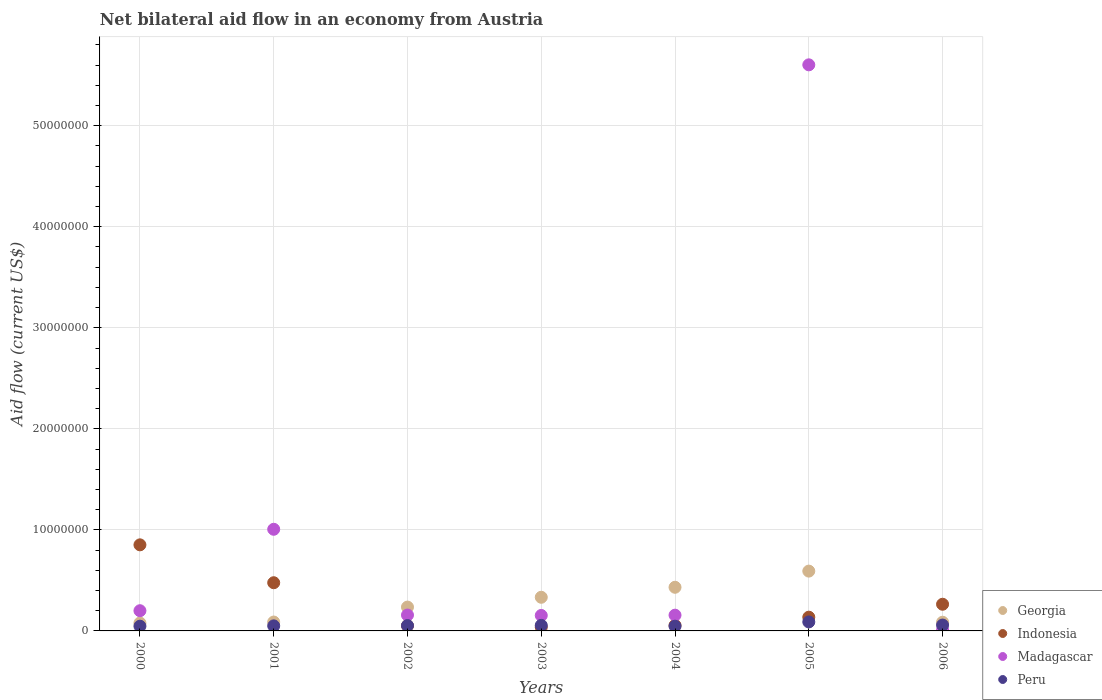How many different coloured dotlines are there?
Keep it short and to the point. 4. Is the number of dotlines equal to the number of legend labels?
Make the answer very short. Yes. What is the net bilateral aid flow in Indonesia in 2005?
Offer a terse response. 1.36e+06. Across all years, what is the maximum net bilateral aid flow in Indonesia?
Your answer should be compact. 8.52e+06. What is the total net bilateral aid flow in Madagascar in the graph?
Your answer should be very brief. 7.28e+07. What is the difference between the net bilateral aid flow in Madagascar in 2005 and the net bilateral aid flow in Peru in 2001?
Keep it short and to the point. 5.55e+07. What is the average net bilateral aid flow in Indonesia per year?
Offer a very short reply. 2.68e+06. In the year 2000, what is the difference between the net bilateral aid flow in Peru and net bilateral aid flow in Georgia?
Your answer should be very brief. -3.10e+05. In how many years, is the net bilateral aid flow in Georgia greater than 54000000 US$?
Provide a short and direct response. 0. What is the ratio of the net bilateral aid flow in Peru in 2000 to that in 2003?
Your response must be concise. 0.85. What is the difference between the highest and the second highest net bilateral aid flow in Peru?
Ensure brevity in your answer.  3.10e+05. What is the difference between the highest and the lowest net bilateral aid flow in Georgia?
Make the answer very short. 5.14e+06. Is the sum of the net bilateral aid flow in Peru in 2005 and 2006 greater than the maximum net bilateral aid flow in Indonesia across all years?
Offer a very short reply. No. How many dotlines are there?
Give a very brief answer. 4. How many years are there in the graph?
Provide a succinct answer. 7. Are the values on the major ticks of Y-axis written in scientific E-notation?
Offer a very short reply. No. Does the graph contain any zero values?
Provide a short and direct response. No. How many legend labels are there?
Give a very brief answer. 4. How are the legend labels stacked?
Keep it short and to the point. Vertical. What is the title of the graph?
Make the answer very short. Net bilateral aid flow in an economy from Austria. What is the label or title of the X-axis?
Your response must be concise. Years. What is the label or title of the Y-axis?
Provide a succinct answer. Aid flow (current US$). What is the Aid flow (current US$) of Georgia in 2000?
Give a very brief answer. 7.80e+05. What is the Aid flow (current US$) in Indonesia in 2000?
Make the answer very short. 8.52e+06. What is the Aid flow (current US$) of Madagascar in 2000?
Provide a short and direct response. 2.00e+06. What is the Aid flow (current US$) of Georgia in 2001?
Provide a short and direct response. 8.80e+05. What is the Aid flow (current US$) in Indonesia in 2001?
Provide a short and direct response. 4.77e+06. What is the Aid flow (current US$) in Madagascar in 2001?
Your answer should be compact. 1.01e+07. What is the Aid flow (current US$) of Georgia in 2002?
Provide a short and direct response. 2.36e+06. What is the Aid flow (current US$) of Indonesia in 2002?
Ensure brevity in your answer.  5.20e+05. What is the Aid flow (current US$) of Madagascar in 2002?
Offer a terse response. 1.57e+06. What is the Aid flow (current US$) in Peru in 2002?
Ensure brevity in your answer.  5.30e+05. What is the Aid flow (current US$) in Georgia in 2003?
Keep it short and to the point. 3.33e+06. What is the Aid flow (current US$) in Indonesia in 2003?
Make the answer very short. 3.70e+05. What is the Aid flow (current US$) in Madagascar in 2003?
Give a very brief answer. 1.53e+06. What is the Aid flow (current US$) in Peru in 2003?
Offer a terse response. 5.50e+05. What is the Aid flow (current US$) of Georgia in 2004?
Provide a short and direct response. 4.32e+06. What is the Aid flow (current US$) in Madagascar in 2004?
Give a very brief answer. 1.56e+06. What is the Aid flow (current US$) of Georgia in 2005?
Your answer should be very brief. 5.92e+06. What is the Aid flow (current US$) in Indonesia in 2005?
Your response must be concise. 1.36e+06. What is the Aid flow (current US$) in Madagascar in 2005?
Ensure brevity in your answer.  5.60e+07. What is the Aid flow (current US$) in Peru in 2005?
Your answer should be very brief. 8.90e+05. What is the Aid flow (current US$) of Georgia in 2006?
Keep it short and to the point. 8.60e+05. What is the Aid flow (current US$) in Indonesia in 2006?
Your answer should be compact. 2.64e+06. What is the Aid flow (current US$) of Peru in 2006?
Keep it short and to the point. 5.80e+05. Across all years, what is the maximum Aid flow (current US$) in Georgia?
Provide a succinct answer. 5.92e+06. Across all years, what is the maximum Aid flow (current US$) of Indonesia?
Give a very brief answer. 8.52e+06. Across all years, what is the maximum Aid flow (current US$) of Madagascar?
Your answer should be very brief. 5.60e+07. Across all years, what is the maximum Aid flow (current US$) in Peru?
Ensure brevity in your answer.  8.90e+05. Across all years, what is the minimum Aid flow (current US$) of Georgia?
Your answer should be compact. 7.80e+05. Across all years, what is the minimum Aid flow (current US$) in Madagascar?
Your answer should be very brief. 9.00e+04. What is the total Aid flow (current US$) of Georgia in the graph?
Provide a short and direct response. 1.84e+07. What is the total Aid flow (current US$) of Indonesia in the graph?
Your answer should be compact. 1.87e+07. What is the total Aid flow (current US$) in Madagascar in the graph?
Your answer should be compact. 7.28e+07. What is the total Aid flow (current US$) in Peru in the graph?
Offer a very short reply. 3.99e+06. What is the difference between the Aid flow (current US$) of Georgia in 2000 and that in 2001?
Provide a short and direct response. -1.00e+05. What is the difference between the Aid flow (current US$) of Indonesia in 2000 and that in 2001?
Give a very brief answer. 3.75e+06. What is the difference between the Aid flow (current US$) in Madagascar in 2000 and that in 2001?
Offer a very short reply. -8.06e+06. What is the difference between the Aid flow (current US$) of Georgia in 2000 and that in 2002?
Your answer should be compact. -1.58e+06. What is the difference between the Aid flow (current US$) in Indonesia in 2000 and that in 2002?
Ensure brevity in your answer.  8.00e+06. What is the difference between the Aid flow (current US$) of Peru in 2000 and that in 2002?
Provide a short and direct response. -6.00e+04. What is the difference between the Aid flow (current US$) of Georgia in 2000 and that in 2003?
Your answer should be compact. -2.55e+06. What is the difference between the Aid flow (current US$) in Indonesia in 2000 and that in 2003?
Offer a very short reply. 8.15e+06. What is the difference between the Aid flow (current US$) of Georgia in 2000 and that in 2004?
Offer a terse response. -3.54e+06. What is the difference between the Aid flow (current US$) in Indonesia in 2000 and that in 2004?
Your response must be concise. 7.97e+06. What is the difference between the Aid flow (current US$) of Madagascar in 2000 and that in 2004?
Provide a short and direct response. 4.40e+05. What is the difference between the Aid flow (current US$) in Peru in 2000 and that in 2004?
Your answer should be compact. 0. What is the difference between the Aid flow (current US$) of Georgia in 2000 and that in 2005?
Offer a terse response. -5.14e+06. What is the difference between the Aid flow (current US$) of Indonesia in 2000 and that in 2005?
Offer a very short reply. 7.16e+06. What is the difference between the Aid flow (current US$) of Madagascar in 2000 and that in 2005?
Give a very brief answer. -5.40e+07. What is the difference between the Aid flow (current US$) of Peru in 2000 and that in 2005?
Keep it short and to the point. -4.20e+05. What is the difference between the Aid flow (current US$) of Georgia in 2000 and that in 2006?
Make the answer very short. -8.00e+04. What is the difference between the Aid flow (current US$) of Indonesia in 2000 and that in 2006?
Provide a short and direct response. 5.88e+06. What is the difference between the Aid flow (current US$) in Madagascar in 2000 and that in 2006?
Keep it short and to the point. 1.91e+06. What is the difference between the Aid flow (current US$) of Peru in 2000 and that in 2006?
Keep it short and to the point. -1.10e+05. What is the difference between the Aid flow (current US$) in Georgia in 2001 and that in 2002?
Give a very brief answer. -1.48e+06. What is the difference between the Aid flow (current US$) in Indonesia in 2001 and that in 2002?
Your answer should be compact. 4.25e+06. What is the difference between the Aid flow (current US$) in Madagascar in 2001 and that in 2002?
Keep it short and to the point. 8.49e+06. What is the difference between the Aid flow (current US$) in Peru in 2001 and that in 2002?
Offer a terse response. -3.00e+04. What is the difference between the Aid flow (current US$) in Georgia in 2001 and that in 2003?
Your response must be concise. -2.45e+06. What is the difference between the Aid flow (current US$) in Indonesia in 2001 and that in 2003?
Ensure brevity in your answer.  4.40e+06. What is the difference between the Aid flow (current US$) in Madagascar in 2001 and that in 2003?
Give a very brief answer. 8.53e+06. What is the difference between the Aid flow (current US$) of Peru in 2001 and that in 2003?
Provide a short and direct response. -5.00e+04. What is the difference between the Aid flow (current US$) of Georgia in 2001 and that in 2004?
Your answer should be very brief. -3.44e+06. What is the difference between the Aid flow (current US$) of Indonesia in 2001 and that in 2004?
Ensure brevity in your answer.  4.22e+06. What is the difference between the Aid flow (current US$) in Madagascar in 2001 and that in 2004?
Ensure brevity in your answer.  8.50e+06. What is the difference between the Aid flow (current US$) of Peru in 2001 and that in 2004?
Ensure brevity in your answer.  3.00e+04. What is the difference between the Aid flow (current US$) of Georgia in 2001 and that in 2005?
Your answer should be compact. -5.04e+06. What is the difference between the Aid flow (current US$) of Indonesia in 2001 and that in 2005?
Make the answer very short. 3.41e+06. What is the difference between the Aid flow (current US$) in Madagascar in 2001 and that in 2005?
Provide a succinct answer. -4.60e+07. What is the difference between the Aid flow (current US$) in Peru in 2001 and that in 2005?
Give a very brief answer. -3.90e+05. What is the difference between the Aid flow (current US$) of Georgia in 2001 and that in 2006?
Keep it short and to the point. 2.00e+04. What is the difference between the Aid flow (current US$) in Indonesia in 2001 and that in 2006?
Your response must be concise. 2.13e+06. What is the difference between the Aid flow (current US$) of Madagascar in 2001 and that in 2006?
Ensure brevity in your answer.  9.97e+06. What is the difference between the Aid flow (current US$) in Peru in 2001 and that in 2006?
Keep it short and to the point. -8.00e+04. What is the difference between the Aid flow (current US$) of Georgia in 2002 and that in 2003?
Your answer should be very brief. -9.70e+05. What is the difference between the Aid flow (current US$) in Peru in 2002 and that in 2003?
Ensure brevity in your answer.  -2.00e+04. What is the difference between the Aid flow (current US$) in Georgia in 2002 and that in 2004?
Offer a terse response. -1.96e+06. What is the difference between the Aid flow (current US$) in Indonesia in 2002 and that in 2004?
Your answer should be compact. -3.00e+04. What is the difference between the Aid flow (current US$) of Peru in 2002 and that in 2004?
Your answer should be compact. 6.00e+04. What is the difference between the Aid flow (current US$) of Georgia in 2002 and that in 2005?
Make the answer very short. -3.56e+06. What is the difference between the Aid flow (current US$) in Indonesia in 2002 and that in 2005?
Ensure brevity in your answer.  -8.40e+05. What is the difference between the Aid flow (current US$) in Madagascar in 2002 and that in 2005?
Provide a succinct answer. -5.45e+07. What is the difference between the Aid flow (current US$) of Peru in 2002 and that in 2005?
Your response must be concise. -3.60e+05. What is the difference between the Aid flow (current US$) in Georgia in 2002 and that in 2006?
Offer a terse response. 1.50e+06. What is the difference between the Aid flow (current US$) in Indonesia in 2002 and that in 2006?
Make the answer very short. -2.12e+06. What is the difference between the Aid flow (current US$) in Madagascar in 2002 and that in 2006?
Offer a terse response. 1.48e+06. What is the difference between the Aid flow (current US$) in Georgia in 2003 and that in 2004?
Give a very brief answer. -9.90e+05. What is the difference between the Aid flow (current US$) of Georgia in 2003 and that in 2005?
Offer a very short reply. -2.59e+06. What is the difference between the Aid flow (current US$) in Indonesia in 2003 and that in 2005?
Give a very brief answer. -9.90e+05. What is the difference between the Aid flow (current US$) in Madagascar in 2003 and that in 2005?
Offer a very short reply. -5.45e+07. What is the difference between the Aid flow (current US$) in Georgia in 2003 and that in 2006?
Give a very brief answer. 2.47e+06. What is the difference between the Aid flow (current US$) in Indonesia in 2003 and that in 2006?
Offer a terse response. -2.27e+06. What is the difference between the Aid flow (current US$) of Madagascar in 2003 and that in 2006?
Ensure brevity in your answer.  1.44e+06. What is the difference between the Aid flow (current US$) in Georgia in 2004 and that in 2005?
Your answer should be compact. -1.60e+06. What is the difference between the Aid flow (current US$) in Indonesia in 2004 and that in 2005?
Your answer should be compact. -8.10e+05. What is the difference between the Aid flow (current US$) in Madagascar in 2004 and that in 2005?
Ensure brevity in your answer.  -5.45e+07. What is the difference between the Aid flow (current US$) of Peru in 2004 and that in 2005?
Provide a short and direct response. -4.20e+05. What is the difference between the Aid flow (current US$) in Georgia in 2004 and that in 2006?
Keep it short and to the point. 3.46e+06. What is the difference between the Aid flow (current US$) of Indonesia in 2004 and that in 2006?
Provide a succinct answer. -2.09e+06. What is the difference between the Aid flow (current US$) in Madagascar in 2004 and that in 2006?
Provide a short and direct response. 1.47e+06. What is the difference between the Aid flow (current US$) in Georgia in 2005 and that in 2006?
Provide a succinct answer. 5.06e+06. What is the difference between the Aid flow (current US$) of Indonesia in 2005 and that in 2006?
Your answer should be compact. -1.28e+06. What is the difference between the Aid flow (current US$) in Madagascar in 2005 and that in 2006?
Give a very brief answer. 5.59e+07. What is the difference between the Aid flow (current US$) of Peru in 2005 and that in 2006?
Provide a short and direct response. 3.10e+05. What is the difference between the Aid flow (current US$) in Georgia in 2000 and the Aid flow (current US$) in Indonesia in 2001?
Ensure brevity in your answer.  -3.99e+06. What is the difference between the Aid flow (current US$) of Georgia in 2000 and the Aid flow (current US$) of Madagascar in 2001?
Keep it short and to the point. -9.28e+06. What is the difference between the Aid flow (current US$) of Indonesia in 2000 and the Aid flow (current US$) of Madagascar in 2001?
Give a very brief answer. -1.54e+06. What is the difference between the Aid flow (current US$) in Indonesia in 2000 and the Aid flow (current US$) in Peru in 2001?
Your answer should be very brief. 8.02e+06. What is the difference between the Aid flow (current US$) of Madagascar in 2000 and the Aid flow (current US$) of Peru in 2001?
Your answer should be very brief. 1.50e+06. What is the difference between the Aid flow (current US$) of Georgia in 2000 and the Aid flow (current US$) of Madagascar in 2002?
Make the answer very short. -7.90e+05. What is the difference between the Aid flow (current US$) in Indonesia in 2000 and the Aid flow (current US$) in Madagascar in 2002?
Make the answer very short. 6.95e+06. What is the difference between the Aid flow (current US$) in Indonesia in 2000 and the Aid flow (current US$) in Peru in 2002?
Provide a short and direct response. 7.99e+06. What is the difference between the Aid flow (current US$) of Madagascar in 2000 and the Aid flow (current US$) of Peru in 2002?
Provide a short and direct response. 1.47e+06. What is the difference between the Aid flow (current US$) in Georgia in 2000 and the Aid flow (current US$) in Madagascar in 2003?
Offer a terse response. -7.50e+05. What is the difference between the Aid flow (current US$) in Indonesia in 2000 and the Aid flow (current US$) in Madagascar in 2003?
Your response must be concise. 6.99e+06. What is the difference between the Aid flow (current US$) in Indonesia in 2000 and the Aid flow (current US$) in Peru in 2003?
Provide a succinct answer. 7.97e+06. What is the difference between the Aid flow (current US$) in Madagascar in 2000 and the Aid flow (current US$) in Peru in 2003?
Offer a terse response. 1.45e+06. What is the difference between the Aid flow (current US$) in Georgia in 2000 and the Aid flow (current US$) in Indonesia in 2004?
Keep it short and to the point. 2.30e+05. What is the difference between the Aid flow (current US$) in Georgia in 2000 and the Aid flow (current US$) in Madagascar in 2004?
Your answer should be compact. -7.80e+05. What is the difference between the Aid flow (current US$) of Georgia in 2000 and the Aid flow (current US$) of Peru in 2004?
Ensure brevity in your answer.  3.10e+05. What is the difference between the Aid flow (current US$) in Indonesia in 2000 and the Aid flow (current US$) in Madagascar in 2004?
Your answer should be compact. 6.96e+06. What is the difference between the Aid flow (current US$) of Indonesia in 2000 and the Aid flow (current US$) of Peru in 2004?
Your response must be concise. 8.05e+06. What is the difference between the Aid flow (current US$) in Madagascar in 2000 and the Aid flow (current US$) in Peru in 2004?
Keep it short and to the point. 1.53e+06. What is the difference between the Aid flow (current US$) in Georgia in 2000 and the Aid flow (current US$) in Indonesia in 2005?
Your answer should be compact. -5.80e+05. What is the difference between the Aid flow (current US$) in Georgia in 2000 and the Aid flow (current US$) in Madagascar in 2005?
Offer a terse response. -5.52e+07. What is the difference between the Aid flow (current US$) of Indonesia in 2000 and the Aid flow (current US$) of Madagascar in 2005?
Ensure brevity in your answer.  -4.75e+07. What is the difference between the Aid flow (current US$) of Indonesia in 2000 and the Aid flow (current US$) of Peru in 2005?
Offer a very short reply. 7.63e+06. What is the difference between the Aid flow (current US$) in Madagascar in 2000 and the Aid flow (current US$) in Peru in 2005?
Your answer should be very brief. 1.11e+06. What is the difference between the Aid flow (current US$) in Georgia in 2000 and the Aid flow (current US$) in Indonesia in 2006?
Provide a short and direct response. -1.86e+06. What is the difference between the Aid flow (current US$) in Georgia in 2000 and the Aid flow (current US$) in Madagascar in 2006?
Make the answer very short. 6.90e+05. What is the difference between the Aid flow (current US$) of Indonesia in 2000 and the Aid flow (current US$) of Madagascar in 2006?
Provide a succinct answer. 8.43e+06. What is the difference between the Aid flow (current US$) of Indonesia in 2000 and the Aid flow (current US$) of Peru in 2006?
Offer a very short reply. 7.94e+06. What is the difference between the Aid flow (current US$) of Madagascar in 2000 and the Aid flow (current US$) of Peru in 2006?
Offer a terse response. 1.42e+06. What is the difference between the Aid flow (current US$) of Georgia in 2001 and the Aid flow (current US$) of Madagascar in 2002?
Your response must be concise. -6.90e+05. What is the difference between the Aid flow (current US$) of Georgia in 2001 and the Aid flow (current US$) of Peru in 2002?
Your response must be concise. 3.50e+05. What is the difference between the Aid flow (current US$) of Indonesia in 2001 and the Aid flow (current US$) of Madagascar in 2002?
Your answer should be very brief. 3.20e+06. What is the difference between the Aid flow (current US$) in Indonesia in 2001 and the Aid flow (current US$) in Peru in 2002?
Keep it short and to the point. 4.24e+06. What is the difference between the Aid flow (current US$) of Madagascar in 2001 and the Aid flow (current US$) of Peru in 2002?
Offer a terse response. 9.53e+06. What is the difference between the Aid flow (current US$) in Georgia in 2001 and the Aid flow (current US$) in Indonesia in 2003?
Give a very brief answer. 5.10e+05. What is the difference between the Aid flow (current US$) in Georgia in 2001 and the Aid flow (current US$) in Madagascar in 2003?
Provide a succinct answer. -6.50e+05. What is the difference between the Aid flow (current US$) of Georgia in 2001 and the Aid flow (current US$) of Peru in 2003?
Offer a terse response. 3.30e+05. What is the difference between the Aid flow (current US$) in Indonesia in 2001 and the Aid flow (current US$) in Madagascar in 2003?
Your answer should be compact. 3.24e+06. What is the difference between the Aid flow (current US$) in Indonesia in 2001 and the Aid flow (current US$) in Peru in 2003?
Ensure brevity in your answer.  4.22e+06. What is the difference between the Aid flow (current US$) of Madagascar in 2001 and the Aid flow (current US$) of Peru in 2003?
Offer a terse response. 9.51e+06. What is the difference between the Aid flow (current US$) of Georgia in 2001 and the Aid flow (current US$) of Madagascar in 2004?
Your answer should be compact. -6.80e+05. What is the difference between the Aid flow (current US$) in Indonesia in 2001 and the Aid flow (current US$) in Madagascar in 2004?
Ensure brevity in your answer.  3.21e+06. What is the difference between the Aid flow (current US$) of Indonesia in 2001 and the Aid flow (current US$) of Peru in 2004?
Your answer should be compact. 4.30e+06. What is the difference between the Aid flow (current US$) in Madagascar in 2001 and the Aid flow (current US$) in Peru in 2004?
Provide a short and direct response. 9.59e+06. What is the difference between the Aid flow (current US$) in Georgia in 2001 and the Aid flow (current US$) in Indonesia in 2005?
Ensure brevity in your answer.  -4.80e+05. What is the difference between the Aid flow (current US$) in Georgia in 2001 and the Aid flow (current US$) in Madagascar in 2005?
Your answer should be compact. -5.52e+07. What is the difference between the Aid flow (current US$) of Indonesia in 2001 and the Aid flow (current US$) of Madagascar in 2005?
Make the answer very short. -5.13e+07. What is the difference between the Aid flow (current US$) in Indonesia in 2001 and the Aid flow (current US$) in Peru in 2005?
Your answer should be very brief. 3.88e+06. What is the difference between the Aid flow (current US$) in Madagascar in 2001 and the Aid flow (current US$) in Peru in 2005?
Ensure brevity in your answer.  9.17e+06. What is the difference between the Aid flow (current US$) of Georgia in 2001 and the Aid flow (current US$) of Indonesia in 2006?
Provide a short and direct response. -1.76e+06. What is the difference between the Aid flow (current US$) of Georgia in 2001 and the Aid flow (current US$) of Madagascar in 2006?
Your answer should be compact. 7.90e+05. What is the difference between the Aid flow (current US$) in Georgia in 2001 and the Aid flow (current US$) in Peru in 2006?
Make the answer very short. 3.00e+05. What is the difference between the Aid flow (current US$) of Indonesia in 2001 and the Aid flow (current US$) of Madagascar in 2006?
Make the answer very short. 4.68e+06. What is the difference between the Aid flow (current US$) of Indonesia in 2001 and the Aid flow (current US$) of Peru in 2006?
Provide a succinct answer. 4.19e+06. What is the difference between the Aid flow (current US$) of Madagascar in 2001 and the Aid flow (current US$) of Peru in 2006?
Your answer should be compact. 9.48e+06. What is the difference between the Aid flow (current US$) of Georgia in 2002 and the Aid flow (current US$) of Indonesia in 2003?
Make the answer very short. 1.99e+06. What is the difference between the Aid flow (current US$) in Georgia in 2002 and the Aid flow (current US$) in Madagascar in 2003?
Your answer should be compact. 8.30e+05. What is the difference between the Aid flow (current US$) in Georgia in 2002 and the Aid flow (current US$) in Peru in 2003?
Provide a succinct answer. 1.81e+06. What is the difference between the Aid flow (current US$) in Indonesia in 2002 and the Aid flow (current US$) in Madagascar in 2003?
Your answer should be compact. -1.01e+06. What is the difference between the Aid flow (current US$) in Indonesia in 2002 and the Aid flow (current US$) in Peru in 2003?
Make the answer very short. -3.00e+04. What is the difference between the Aid flow (current US$) in Madagascar in 2002 and the Aid flow (current US$) in Peru in 2003?
Offer a terse response. 1.02e+06. What is the difference between the Aid flow (current US$) in Georgia in 2002 and the Aid flow (current US$) in Indonesia in 2004?
Your answer should be compact. 1.81e+06. What is the difference between the Aid flow (current US$) in Georgia in 2002 and the Aid flow (current US$) in Madagascar in 2004?
Provide a succinct answer. 8.00e+05. What is the difference between the Aid flow (current US$) of Georgia in 2002 and the Aid flow (current US$) of Peru in 2004?
Offer a very short reply. 1.89e+06. What is the difference between the Aid flow (current US$) in Indonesia in 2002 and the Aid flow (current US$) in Madagascar in 2004?
Your answer should be compact. -1.04e+06. What is the difference between the Aid flow (current US$) of Indonesia in 2002 and the Aid flow (current US$) of Peru in 2004?
Give a very brief answer. 5.00e+04. What is the difference between the Aid flow (current US$) of Madagascar in 2002 and the Aid flow (current US$) of Peru in 2004?
Keep it short and to the point. 1.10e+06. What is the difference between the Aid flow (current US$) of Georgia in 2002 and the Aid flow (current US$) of Madagascar in 2005?
Ensure brevity in your answer.  -5.37e+07. What is the difference between the Aid flow (current US$) of Georgia in 2002 and the Aid flow (current US$) of Peru in 2005?
Your response must be concise. 1.47e+06. What is the difference between the Aid flow (current US$) in Indonesia in 2002 and the Aid flow (current US$) in Madagascar in 2005?
Ensure brevity in your answer.  -5.55e+07. What is the difference between the Aid flow (current US$) of Indonesia in 2002 and the Aid flow (current US$) of Peru in 2005?
Your answer should be very brief. -3.70e+05. What is the difference between the Aid flow (current US$) in Madagascar in 2002 and the Aid flow (current US$) in Peru in 2005?
Provide a succinct answer. 6.80e+05. What is the difference between the Aid flow (current US$) in Georgia in 2002 and the Aid flow (current US$) in Indonesia in 2006?
Offer a terse response. -2.80e+05. What is the difference between the Aid flow (current US$) in Georgia in 2002 and the Aid flow (current US$) in Madagascar in 2006?
Your response must be concise. 2.27e+06. What is the difference between the Aid flow (current US$) of Georgia in 2002 and the Aid flow (current US$) of Peru in 2006?
Your answer should be compact. 1.78e+06. What is the difference between the Aid flow (current US$) in Indonesia in 2002 and the Aid flow (current US$) in Madagascar in 2006?
Provide a succinct answer. 4.30e+05. What is the difference between the Aid flow (current US$) in Indonesia in 2002 and the Aid flow (current US$) in Peru in 2006?
Provide a succinct answer. -6.00e+04. What is the difference between the Aid flow (current US$) in Madagascar in 2002 and the Aid flow (current US$) in Peru in 2006?
Give a very brief answer. 9.90e+05. What is the difference between the Aid flow (current US$) of Georgia in 2003 and the Aid flow (current US$) of Indonesia in 2004?
Offer a terse response. 2.78e+06. What is the difference between the Aid flow (current US$) in Georgia in 2003 and the Aid flow (current US$) in Madagascar in 2004?
Ensure brevity in your answer.  1.77e+06. What is the difference between the Aid flow (current US$) of Georgia in 2003 and the Aid flow (current US$) of Peru in 2004?
Give a very brief answer. 2.86e+06. What is the difference between the Aid flow (current US$) in Indonesia in 2003 and the Aid flow (current US$) in Madagascar in 2004?
Your answer should be compact. -1.19e+06. What is the difference between the Aid flow (current US$) in Madagascar in 2003 and the Aid flow (current US$) in Peru in 2004?
Your answer should be compact. 1.06e+06. What is the difference between the Aid flow (current US$) in Georgia in 2003 and the Aid flow (current US$) in Indonesia in 2005?
Offer a terse response. 1.97e+06. What is the difference between the Aid flow (current US$) in Georgia in 2003 and the Aid flow (current US$) in Madagascar in 2005?
Your answer should be compact. -5.27e+07. What is the difference between the Aid flow (current US$) of Georgia in 2003 and the Aid flow (current US$) of Peru in 2005?
Provide a succinct answer. 2.44e+06. What is the difference between the Aid flow (current US$) in Indonesia in 2003 and the Aid flow (current US$) in Madagascar in 2005?
Offer a terse response. -5.57e+07. What is the difference between the Aid flow (current US$) of Indonesia in 2003 and the Aid flow (current US$) of Peru in 2005?
Provide a succinct answer. -5.20e+05. What is the difference between the Aid flow (current US$) of Madagascar in 2003 and the Aid flow (current US$) of Peru in 2005?
Ensure brevity in your answer.  6.40e+05. What is the difference between the Aid flow (current US$) of Georgia in 2003 and the Aid flow (current US$) of Indonesia in 2006?
Ensure brevity in your answer.  6.90e+05. What is the difference between the Aid flow (current US$) in Georgia in 2003 and the Aid flow (current US$) in Madagascar in 2006?
Provide a succinct answer. 3.24e+06. What is the difference between the Aid flow (current US$) in Georgia in 2003 and the Aid flow (current US$) in Peru in 2006?
Provide a succinct answer. 2.75e+06. What is the difference between the Aid flow (current US$) in Indonesia in 2003 and the Aid flow (current US$) in Madagascar in 2006?
Give a very brief answer. 2.80e+05. What is the difference between the Aid flow (current US$) of Indonesia in 2003 and the Aid flow (current US$) of Peru in 2006?
Provide a succinct answer. -2.10e+05. What is the difference between the Aid flow (current US$) in Madagascar in 2003 and the Aid flow (current US$) in Peru in 2006?
Offer a terse response. 9.50e+05. What is the difference between the Aid flow (current US$) of Georgia in 2004 and the Aid flow (current US$) of Indonesia in 2005?
Ensure brevity in your answer.  2.96e+06. What is the difference between the Aid flow (current US$) in Georgia in 2004 and the Aid flow (current US$) in Madagascar in 2005?
Provide a short and direct response. -5.17e+07. What is the difference between the Aid flow (current US$) in Georgia in 2004 and the Aid flow (current US$) in Peru in 2005?
Give a very brief answer. 3.43e+06. What is the difference between the Aid flow (current US$) in Indonesia in 2004 and the Aid flow (current US$) in Madagascar in 2005?
Offer a very short reply. -5.55e+07. What is the difference between the Aid flow (current US$) in Madagascar in 2004 and the Aid flow (current US$) in Peru in 2005?
Ensure brevity in your answer.  6.70e+05. What is the difference between the Aid flow (current US$) in Georgia in 2004 and the Aid flow (current US$) in Indonesia in 2006?
Offer a very short reply. 1.68e+06. What is the difference between the Aid flow (current US$) of Georgia in 2004 and the Aid flow (current US$) of Madagascar in 2006?
Provide a succinct answer. 4.23e+06. What is the difference between the Aid flow (current US$) of Georgia in 2004 and the Aid flow (current US$) of Peru in 2006?
Ensure brevity in your answer.  3.74e+06. What is the difference between the Aid flow (current US$) of Madagascar in 2004 and the Aid flow (current US$) of Peru in 2006?
Your answer should be very brief. 9.80e+05. What is the difference between the Aid flow (current US$) in Georgia in 2005 and the Aid flow (current US$) in Indonesia in 2006?
Your answer should be very brief. 3.28e+06. What is the difference between the Aid flow (current US$) in Georgia in 2005 and the Aid flow (current US$) in Madagascar in 2006?
Keep it short and to the point. 5.83e+06. What is the difference between the Aid flow (current US$) in Georgia in 2005 and the Aid flow (current US$) in Peru in 2006?
Your response must be concise. 5.34e+06. What is the difference between the Aid flow (current US$) in Indonesia in 2005 and the Aid flow (current US$) in Madagascar in 2006?
Keep it short and to the point. 1.27e+06. What is the difference between the Aid flow (current US$) of Indonesia in 2005 and the Aid flow (current US$) of Peru in 2006?
Offer a terse response. 7.80e+05. What is the difference between the Aid flow (current US$) in Madagascar in 2005 and the Aid flow (current US$) in Peru in 2006?
Offer a terse response. 5.54e+07. What is the average Aid flow (current US$) in Georgia per year?
Your response must be concise. 2.64e+06. What is the average Aid flow (current US$) of Indonesia per year?
Offer a very short reply. 2.68e+06. What is the average Aid flow (current US$) of Madagascar per year?
Offer a terse response. 1.04e+07. What is the average Aid flow (current US$) in Peru per year?
Your response must be concise. 5.70e+05. In the year 2000, what is the difference between the Aid flow (current US$) in Georgia and Aid flow (current US$) in Indonesia?
Offer a very short reply. -7.74e+06. In the year 2000, what is the difference between the Aid flow (current US$) in Georgia and Aid flow (current US$) in Madagascar?
Your response must be concise. -1.22e+06. In the year 2000, what is the difference between the Aid flow (current US$) in Indonesia and Aid flow (current US$) in Madagascar?
Offer a terse response. 6.52e+06. In the year 2000, what is the difference between the Aid flow (current US$) of Indonesia and Aid flow (current US$) of Peru?
Ensure brevity in your answer.  8.05e+06. In the year 2000, what is the difference between the Aid flow (current US$) in Madagascar and Aid flow (current US$) in Peru?
Your response must be concise. 1.53e+06. In the year 2001, what is the difference between the Aid flow (current US$) in Georgia and Aid flow (current US$) in Indonesia?
Give a very brief answer. -3.89e+06. In the year 2001, what is the difference between the Aid flow (current US$) of Georgia and Aid flow (current US$) of Madagascar?
Your answer should be compact. -9.18e+06. In the year 2001, what is the difference between the Aid flow (current US$) in Indonesia and Aid flow (current US$) in Madagascar?
Offer a very short reply. -5.29e+06. In the year 2001, what is the difference between the Aid flow (current US$) of Indonesia and Aid flow (current US$) of Peru?
Provide a short and direct response. 4.27e+06. In the year 2001, what is the difference between the Aid flow (current US$) of Madagascar and Aid flow (current US$) of Peru?
Make the answer very short. 9.56e+06. In the year 2002, what is the difference between the Aid flow (current US$) of Georgia and Aid flow (current US$) of Indonesia?
Offer a very short reply. 1.84e+06. In the year 2002, what is the difference between the Aid flow (current US$) in Georgia and Aid flow (current US$) in Madagascar?
Ensure brevity in your answer.  7.90e+05. In the year 2002, what is the difference between the Aid flow (current US$) of Georgia and Aid flow (current US$) of Peru?
Offer a very short reply. 1.83e+06. In the year 2002, what is the difference between the Aid flow (current US$) of Indonesia and Aid flow (current US$) of Madagascar?
Make the answer very short. -1.05e+06. In the year 2002, what is the difference between the Aid flow (current US$) of Madagascar and Aid flow (current US$) of Peru?
Your response must be concise. 1.04e+06. In the year 2003, what is the difference between the Aid flow (current US$) of Georgia and Aid flow (current US$) of Indonesia?
Offer a terse response. 2.96e+06. In the year 2003, what is the difference between the Aid flow (current US$) of Georgia and Aid flow (current US$) of Madagascar?
Offer a very short reply. 1.80e+06. In the year 2003, what is the difference between the Aid flow (current US$) in Georgia and Aid flow (current US$) in Peru?
Provide a succinct answer. 2.78e+06. In the year 2003, what is the difference between the Aid flow (current US$) in Indonesia and Aid flow (current US$) in Madagascar?
Your answer should be compact. -1.16e+06. In the year 2003, what is the difference between the Aid flow (current US$) in Madagascar and Aid flow (current US$) in Peru?
Make the answer very short. 9.80e+05. In the year 2004, what is the difference between the Aid flow (current US$) in Georgia and Aid flow (current US$) in Indonesia?
Your response must be concise. 3.77e+06. In the year 2004, what is the difference between the Aid flow (current US$) of Georgia and Aid flow (current US$) of Madagascar?
Make the answer very short. 2.76e+06. In the year 2004, what is the difference between the Aid flow (current US$) in Georgia and Aid flow (current US$) in Peru?
Your answer should be very brief. 3.85e+06. In the year 2004, what is the difference between the Aid flow (current US$) of Indonesia and Aid flow (current US$) of Madagascar?
Your answer should be very brief. -1.01e+06. In the year 2004, what is the difference between the Aid flow (current US$) of Indonesia and Aid flow (current US$) of Peru?
Make the answer very short. 8.00e+04. In the year 2004, what is the difference between the Aid flow (current US$) in Madagascar and Aid flow (current US$) in Peru?
Ensure brevity in your answer.  1.09e+06. In the year 2005, what is the difference between the Aid flow (current US$) in Georgia and Aid flow (current US$) in Indonesia?
Keep it short and to the point. 4.56e+06. In the year 2005, what is the difference between the Aid flow (current US$) in Georgia and Aid flow (current US$) in Madagascar?
Provide a short and direct response. -5.01e+07. In the year 2005, what is the difference between the Aid flow (current US$) of Georgia and Aid flow (current US$) of Peru?
Provide a short and direct response. 5.03e+06. In the year 2005, what is the difference between the Aid flow (current US$) of Indonesia and Aid flow (current US$) of Madagascar?
Make the answer very short. -5.47e+07. In the year 2005, what is the difference between the Aid flow (current US$) in Indonesia and Aid flow (current US$) in Peru?
Ensure brevity in your answer.  4.70e+05. In the year 2005, what is the difference between the Aid flow (current US$) of Madagascar and Aid flow (current US$) of Peru?
Provide a short and direct response. 5.51e+07. In the year 2006, what is the difference between the Aid flow (current US$) in Georgia and Aid flow (current US$) in Indonesia?
Make the answer very short. -1.78e+06. In the year 2006, what is the difference between the Aid flow (current US$) in Georgia and Aid flow (current US$) in Madagascar?
Provide a short and direct response. 7.70e+05. In the year 2006, what is the difference between the Aid flow (current US$) of Georgia and Aid flow (current US$) of Peru?
Make the answer very short. 2.80e+05. In the year 2006, what is the difference between the Aid flow (current US$) of Indonesia and Aid flow (current US$) of Madagascar?
Give a very brief answer. 2.55e+06. In the year 2006, what is the difference between the Aid flow (current US$) of Indonesia and Aid flow (current US$) of Peru?
Make the answer very short. 2.06e+06. In the year 2006, what is the difference between the Aid flow (current US$) in Madagascar and Aid flow (current US$) in Peru?
Make the answer very short. -4.90e+05. What is the ratio of the Aid flow (current US$) in Georgia in 2000 to that in 2001?
Give a very brief answer. 0.89. What is the ratio of the Aid flow (current US$) in Indonesia in 2000 to that in 2001?
Keep it short and to the point. 1.79. What is the ratio of the Aid flow (current US$) of Madagascar in 2000 to that in 2001?
Provide a succinct answer. 0.2. What is the ratio of the Aid flow (current US$) of Georgia in 2000 to that in 2002?
Provide a short and direct response. 0.33. What is the ratio of the Aid flow (current US$) of Indonesia in 2000 to that in 2002?
Your answer should be very brief. 16.38. What is the ratio of the Aid flow (current US$) of Madagascar in 2000 to that in 2002?
Your response must be concise. 1.27. What is the ratio of the Aid flow (current US$) of Peru in 2000 to that in 2002?
Make the answer very short. 0.89. What is the ratio of the Aid flow (current US$) of Georgia in 2000 to that in 2003?
Your response must be concise. 0.23. What is the ratio of the Aid flow (current US$) in Indonesia in 2000 to that in 2003?
Make the answer very short. 23.03. What is the ratio of the Aid flow (current US$) in Madagascar in 2000 to that in 2003?
Your answer should be compact. 1.31. What is the ratio of the Aid flow (current US$) in Peru in 2000 to that in 2003?
Ensure brevity in your answer.  0.85. What is the ratio of the Aid flow (current US$) in Georgia in 2000 to that in 2004?
Give a very brief answer. 0.18. What is the ratio of the Aid flow (current US$) of Indonesia in 2000 to that in 2004?
Your answer should be compact. 15.49. What is the ratio of the Aid flow (current US$) in Madagascar in 2000 to that in 2004?
Your answer should be compact. 1.28. What is the ratio of the Aid flow (current US$) in Georgia in 2000 to that in 2005?
Provide a succinct answer. 0.13. What is the ratio of the Aid flow (current US$) of Indonesia in 2000 to that in 2005?
Your response must be concise. 6.26. What is the ratio of the Aid flow (current US$) of Madagascar in 2000 to that in 2005?
Ensure brevity in your answer.  0.04. What is the ratio of the Aid flow (current US$) in Peru in 2000 to that in 2005?
Provide a succinct answer. 0.53. What is the ratio of the Aid flow (current US$) of Georgia in 2000 to that in 2006?
Offer a very short reply. 0.91. What is the ratio of the Aid flow (current US$) in Indonesia in 2000 to that in 2006?
Your response must be concise. 3.23. What is the ratio of the Aid flow (current US$) of Madagascar in 2000 to that in 2006?
Offer a terse response. 22.22. What is the ratio of the Aid flow (current US$) in Peru in 2000 to that in 2006?
Provide a succinct answer. 0.81. What is the ratio of the Aid flow (current US$) of Georgia in 2001 to that in 2002?
Give a very brief answer. 0.37. What is the ratio of the Aid flow (current US$) in Indonesia in 2001 to that in 2002?
Provide a succinct answer. 9.17. What is the ratio of the Aid flow (current US$) in Madagascar in 2001 to that in 2002?
Offer a terse response. 6.41. What is the ratio of the Aid flow (current US$) in Peru in 2001 to that in 2002?
Provide a succinct answer. 0.94. What is the ratio of the Aid flow (current US$) of Georgia in 2001 to that in 2003?
Your answer should be compact. 0.26. What is the ratio of the Aid flow (current US$) in Indonesia in 2001 to that in 2003?
Provide a short and direct response. 12.89. What is the ratio of the Aid flow (current US$) of Madagascar in 2001 to that in 2003?
Give a very brief answer. 6.58. What is the ratio of the Aid flow (current US$) in Georgia in 2001 to that in 2004?
Offer a very short reply. 0.2. What is the ratio of the Aid flow (current US$) in Indonesia in 2001 to that in 2004?
Your answer should be very brief. 8.67. What is the ratio of the Aid flow (current US$) in Madagascar in 2001 to that in 2004?
Make the answer very short. 6.45. What is the ratio of the Aid flow (current US$) in Peru in 2001 to that in 2004?
Your answer should be very brief. 1.06. What is the ratio of the Aid flow (current US$) in Georgia in 2001 to that in 2005?
Make the answer very short. 0.15. What is the ratio of the Aid flow (current US$) of Indonesia in 2001 to that in 2005?
Give a very brief answer. 3.51. What is the ratio of the Aid flow (current US$) of Madagascar in 2001 to that in 2005?
Keep it short and to the point. 0.18. What is the ratio of the Aid flow (current US$) in Peru in 2001 to that in 2005?
Offer a very short reply. 0.56. What is the ratio of the Aid flow (current US$) of Georgia in 2001 to that in 2006?
Keep it short and to the point. 1.02. What is the ratio of the Aid flow (current US$) of Indonesia in 2001 to that in 2006?
Your answer should be compact. 1.81. What is the ratio of the Aid flow (current US$) in Madagascar in 2001 to that in 2006?
Offer a terse response. 111.78. What is the ratio of the Aid flow (current US$) of Peru in 2001 to that in 2006?
Offer a very short reply. 0.86. What is the ratio of the Aid flow (current US$) of Georgia in 2002 to that in 2003?
Make the answer very short. 0.71. What is the ratio of the Aid flow (current US$) in Indonesia in 2002 to that in 2003?
Give a very brief answer. 1.41. What is the ratio of the Aid flow (current US$) in Madagascar in 2002 to that in 2003?
Keep it short and to the point. 1.03. What is the ratio of the Aid flow (current US$) in Peru in 2002 to that in 2003?
Provide a succinct answer. 0.96. What is the ratio of the Aid flow (current US$) in Georgia in 2002 to that in 2004?
Keep it short and to the point. 0.55. What is the ratio of the Aid flow (current US$) in Indonesia in 2002 to that in 2004?
Offer a very short reply. 0.95. What is the ratio of the Aid flow (current US$) of Madagascar in 2002 to that in 2004?
Provide a succinct answer. 1.01. What is the ratio of the Aid flow (current US$) in Peru in 2002 to that in 2004?
Provide a succinct answer. 1.13. What is the ratio of the Aid flow (current US$) in Georgia in 2002 to that in 2005?
Make the answer very short. 0.4. What is the ratio of the Aid flow (current US$) of Indonesia in 2002 to that in 2005?
Your answer should be very brief. 0.38. What is the ratio of the Aid flow (current US$) in Madagascar in 2002 to that in 2005?
Your response must be concise. 0.03. What is the ratio of the Aid flow (current US$) of Peru in 2002 to that in 2005?
Provide a succinct answer. 0.6. What is the ratio of the Aid flow (current US$) in Georgia in 2002 to that in 2006?
Your response must be concise. 2.74. What is the ratio of the Aid flow (current US$) in Indonesia in 2002 to that in 2006?
Your answer should be compact. 0.2. What is the ratio of the Aid flow (current US$) in Madagascar in 2002 to that in 2006?
Your answer should be very brief. 17.44. What is the ratio of the Aid flow (current US$) in Peru in 2002 to that in 2006?
Your response must be concise. 0.91. What is the ratio of the Aid flow (current US$) in Georgia in 2003 to that in 2004?
Your answer should be very brief. 0.77. What is the ratio of the Aid flow (current US$) in Indonesia in 2003 to that in 2004?
Your response must be concise. 0.67. What is the ratio of the Aid flow (current US$) of Madagascar in 2003 to that in 2004?
Offer a very short reply. 0.98. What is the ratio of the Aid flow (current US$) in Peru in 2003 to that in 2004?
Your response must be concise. 1.17. What is the ratio of the Aid flow (current US$) in Georgia in 2003 to that in 2005?
Provide a succinct answer. 0.56. What is the ratio of the Aid flow (current US$) of Indonesia in 2003 to that in 2005?
Offer a terse response. 0.27. What is the ratio of the Aid flow (current US$) of Madagascar in 2003 to that in 2005?
Your answer should be very brief. 0.03. What is the ratio of the Aid flow (current US$) in Peru in 2003 to that in 2005?
Offer a very short reply. 0.62. What is the ratio of the Aid flow (current US$) of Georgia in 2003 to that in 2006?
Offer a terse response. 3.87. What is the ratio of the Aid flow (current US$) of Indonesia in 2003 to that in 2006?
Your answer should be very brief. 0.14. What is the ratio of the Aid flow (current US$) of Madagascar in 2003 to that in 2006?
Your answer should be very brief. 17. What is the ratio of the Aid flow (current US$) in Peru in 2003 to that in 2006?
Offer a terse response. 0.95. What is the ratio of the Aid flow (current US$) in Georgia in 2004 to that in 2005?
Give a very brief answer. 0.73. What is the ratio of the Aid flow (current US$) of Indonesia in 2004 to that in 2005?
Ensure brevity in your answer.  0.4. What is the ratio of the Aid flow (current US$) in Madagascar in 2004 to that in 2005?
Provide a succinct answer. 0.03. What is the ratio of the Aid flow (current US$) in Peru in 2004 to that in 2005?
Provide a short and direct response. 0.53. What is the ratio of the Aid flow (current US$) of Georgia in 2004 to that in 2006?
Keep it short and to the point. 5.02. What is the ratio of the Aid flow (current US$) in Indonesia in 2004 to that in 2006?
Keep it short and to the point. 0.21. What is the ratio of the Aid flow (current US$) of Madagascar in 2004 to that in 2006?
Your answer should be very brief. 17.33. What is the ratio of the Aid flow (current US$) in Peru in 2004 to that in 2006?
Your answer should be very brief. 0.81. What is the ratio of the Aid flow (current US$) in Georgia in 2005 to that in 2006?
Ensure brevity in your answer.  6.88. What is the ratio of the Aid flow (current US$) in Indonesia in 2005 to that in 2006?
Offer a terse response. 0.52. What is the ratio of the Aid flow (current US$) of Madagascar in 2005 to that in 2006?
Provide a succinct answer. 622.56. What is the ratio of the Aid flow (current US$) in Peru in 2005 to that in 2006?
Offer a terse response. 1.53. What is the difference between the highest and the second highest Aid flow (current US$) of Georgia?
Provide a succinct answer. 1.60e+06. What is the difference between the highest and the second highest Aid flow (current US$) of Indonesia?
Give a very brief answer. 3.75e+06. What is the difference between the highest and the second highest Aid flow (current US$) of Madagascar?
Keep it short and to the point. 4.60e+07. What is the difference between the highest and the lowest Aid flow (current US$) in Georgia?
Give a very brief answer. 5.14e+06. What is the difference between the highest and the lowest Aid flow (current US$) of Indonesia?
Provide a short and direct response. 8.15e+06. What is the difference between the highest and the lowest Aid flow (current US$) in Madagascar?
Your answer should be compact. 5.59e+07. What is the difference between the highest and the lowest Aid flow (current US$) in Peru?
Keep it short and to the point. 4.20e+05. 